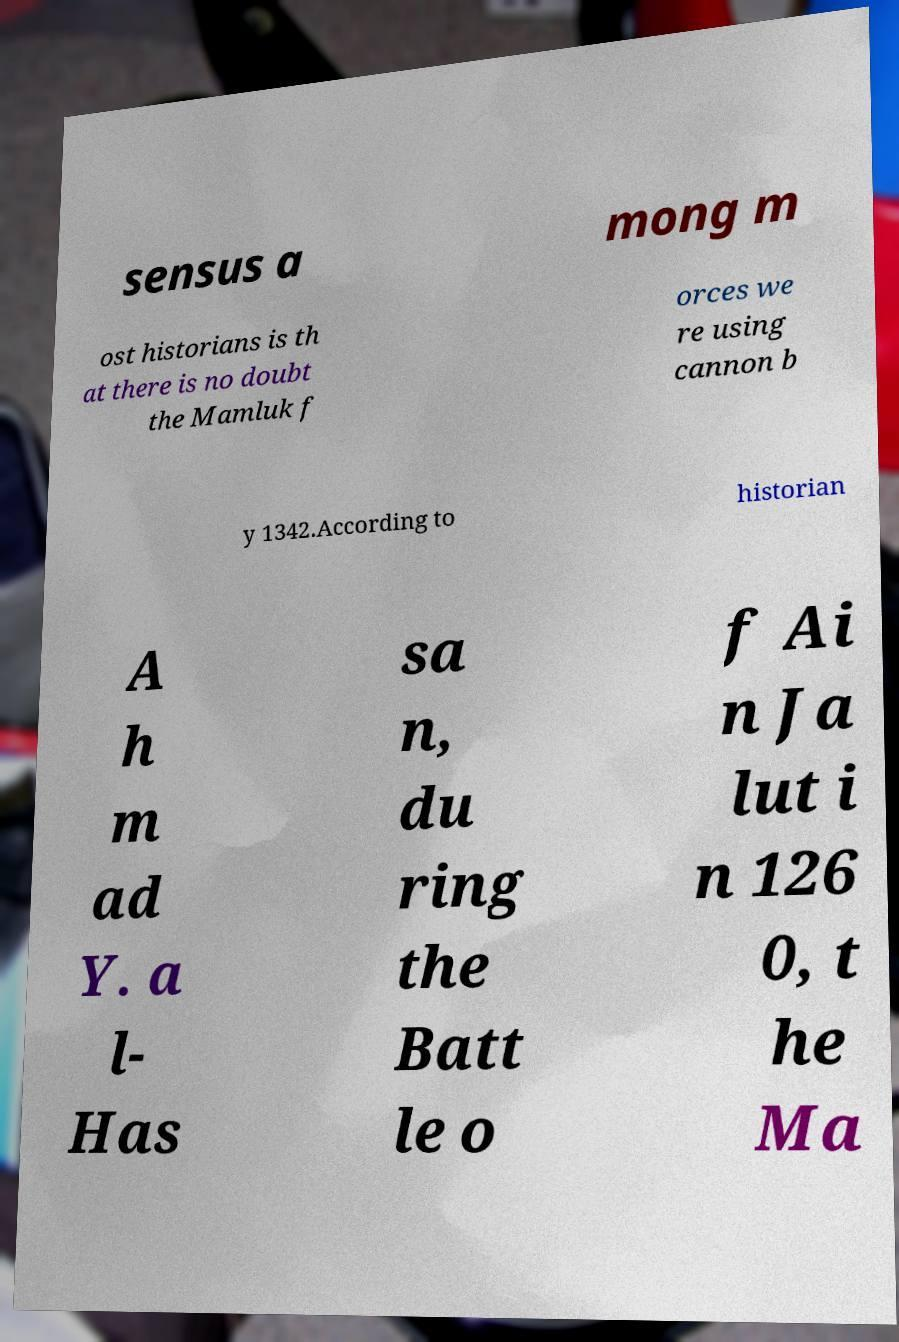Could you extract and type out the text from this image? sensus a mong m ost historians is th at there is no doubt the Mamluk f orces we re using cannon b y 1342.According to historian A h m ad Y. a l- Has sa n, du ring the Batt le o f Ai n Ja lut i n 126 0, t he Ma 